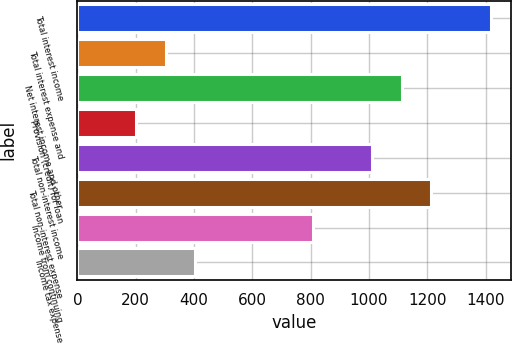<chart> <loc_0><loc_0><loc_500><loc_500><bar_chart><fcel>Total interest income<fcel>Total interest expense and<fcel>Net interest income and other<fcel>Provision (credit) for loan<fcel>Total non-interest income<fcel>Total non-interest expense<fcel>Income from continuing<fcel>Income tax expense<nl><fcel>1416.73<fcel>303.79<fcel>1113.21<fcel>202.61<fcel>1012.04<fcel>1214.38<fcel>809.68<fcel>404.97<nl></chart> 